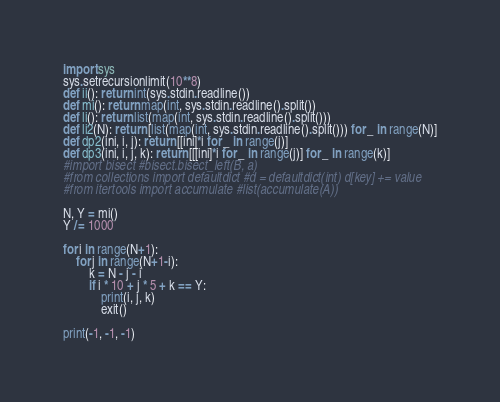<code> <loc_0><loc_0><loc_500><loc_500><_Python_>import sys
sys.setrecursionlimit(10**8)
def ii(): return int(sys.stdin.readline())
def mi(): return map(int, sys.stdin.readline().split())
def li(): return list(map(int, sys.stdin.readline().split()))
def li2(N): return [list(map(int, sys.stdin.readline().split())) for _ in range(N)]
def dp2(ini, i, j): return [[ini]*i for _ in range(j)]
def dp3(ini, i, j, k): return [[[ini]*i for _ in range(j)] for _ in range(k)]
#import bisect #bisect.bisect_left(B, a)
#from collections import defaultdict #d = defaultdict(int) d[key] += value
#from itertools import accumulate #list(accumulate(A))

N, Y = mi()
Y /= 1000

for i in range(N+1):
    for j in range(N+1-i):
        k = N - j - i
        if i * 10 + j * 5 + k == Y:
            print(i, j, k)
            exit()

print(-1, -1, -1)</code> 